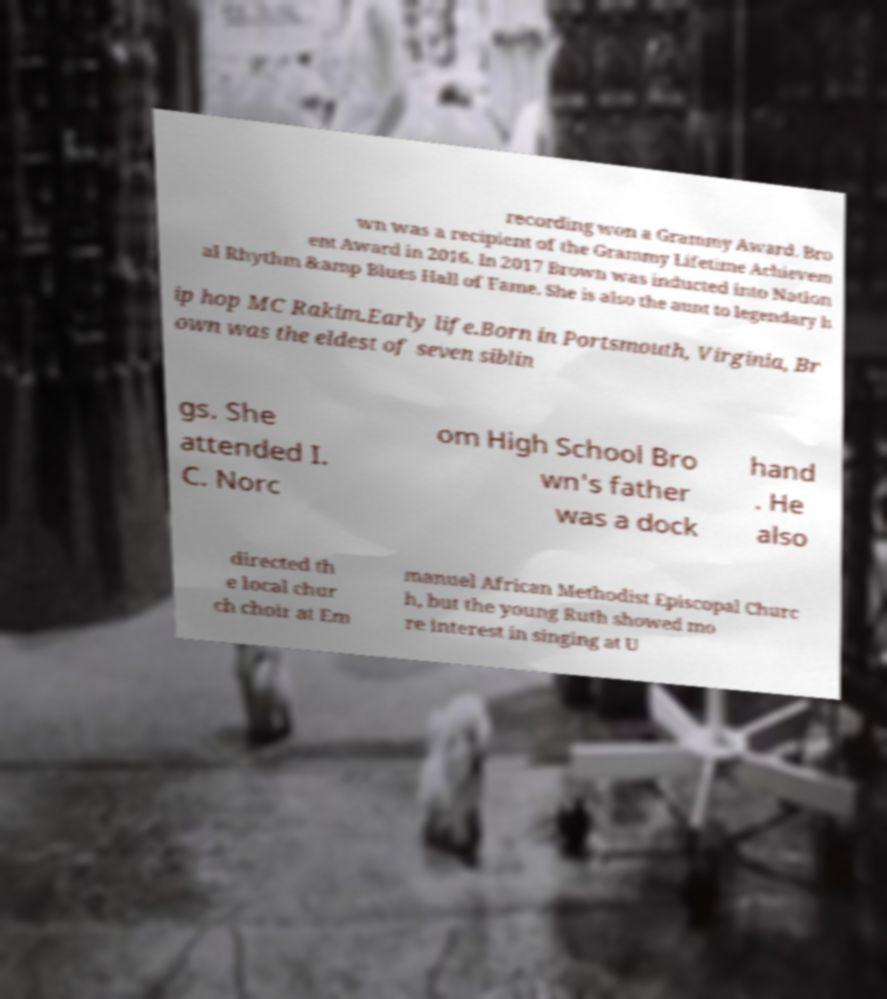Please read and relay the text visible in this image. What does it say? recording won a Grammy Award. Bro wn was a recipient of the Grammy Lifetime Achievem ent Award in 2016. In 2017 Brown was inducted into Nation al Rhythm &amp Blues Hall of Fame. She is also the aunt to legendary h ip hop MC Rakim.Early life.Born in Portsmouth, Virginia, Br own was the eldest of seven siblin gs. She attended I. C. Norc om High School Bro wn's father was a dock hand . He also directed th e local chur ch choir at Em manuel African Methodist Episcopal Churc h, but the young Ruth showed mo re interest in singing at U 